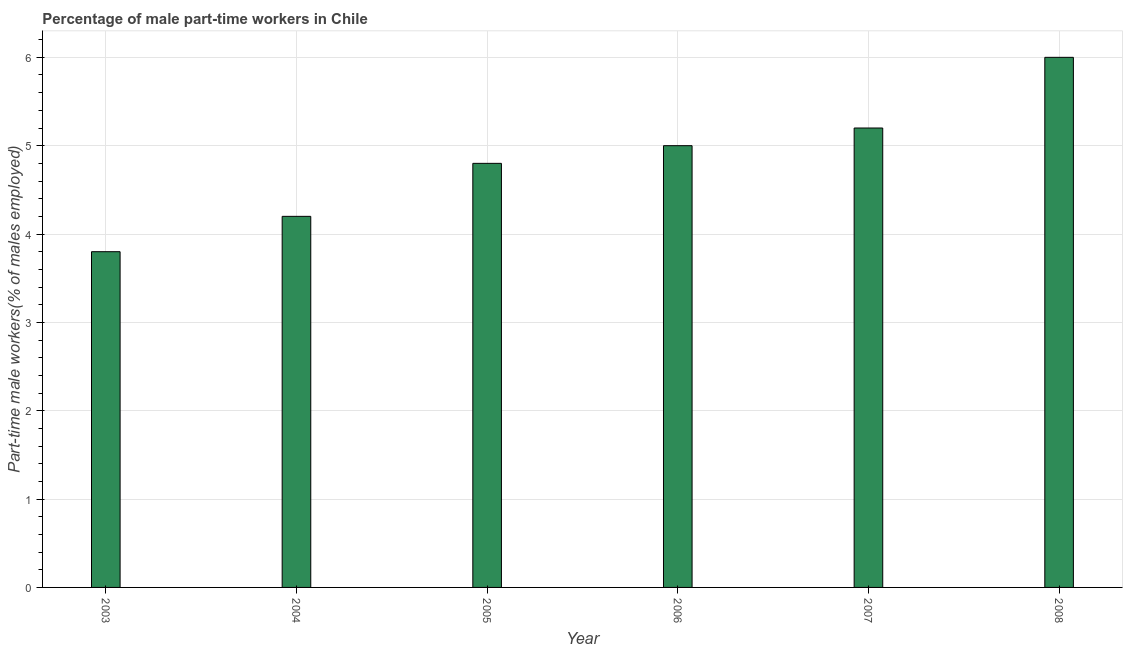Does the graph contain grids?
Keep it short and to the point. Yes. What is the title of the graph?
Give a very brief answer. Percentage of male part-time workers in Chile. What is the label or title of the Y-axis?
Offer a terse response. Part-time male workers(% of males employed). What is the percentage of part-time male workers in 2005?
Your answer should be compact. 4.8. Across all years, what is the maximum percentage of part-time male workers?
Offer a terse response. 6. Across all years, what is the minimum percentage of part-time male workers?
Give a very brief answer. 3.8. In which year was the percentage of part-time male workers maximum?
Provide a short and direct response. 2008. What is the sum of the percentage of part-time male workers?
Your answer should be compact. 29. What is the difference between the percentage of part-time male workers in 2005 and 2007?
Ensure brevity in your answer.  -0.4. What is the average percentage of part-time male workers per year?
Offer a very short reply. 4.83. What is the median percentage of part-time male workers?
Ensure brevity in your answer.  4.9. Do a majority of the years between 2008 and 2004 (inclusive) have percentage of part-time male workers greater than 1.8 %?
Your answer should be very brief. Yes. What is the ratio of the percentage of part-time male workers in 2003 to that in 2004?
Offer a terse response. 0.91. Is the percentage of part-time male workers in 2006 less than that in 2008?
Provide a short and direct response. Yes. Is the difference between the percentage of part-time male workers in 2003 and 2004 greater than the difference between any two years?
Your answer should be very brief. No. Is the sum of the percentage of part-time male workers in 2003 and 2008 greater than the maximum percentage of part-time male workers across all years?
Offer a very short reply. Yes. What is the difference between the highest and the lowest percentage of part-time male workers?
Provide a succinct answer. 2.2. In how many years, is the percentage of part-time male workers greater than the average percentage of part-time male workers taken over all years?
Give a very brief answer. 3. How many bars are there?
Offer a terse response. 6. Are all the bars in the graph horizontal?
Offer a very short reply. No. What is the difference between two consecutive major ticks on the Y-axis?
Give a very brief answer. 1. What is the Part-time male workers(% of males employed) in 2003?
Offer a very short reply. 3.8. What is the Part-time male workers(% of males employed) of 2004?
Keep it short and to the point. 4.2. What is the Part-time male workers(% of males employed) of 2005?
Offer a very short reply. 4.8. What is the Part-time male workers(% of males employed) in 2006?
Your response must be concise. 5. What is the Part-time male workers(% of males employed) in 2007?
Provide a succinct answer. 5.2. What is the Part-time male workers(% of males employed) in 2008?
Your answer should be very brief. 6. What is the difference between the Part-time male workers(% of males employed) in 2003 and 2004?
Offer a very short reply. -0.4. What is the difference between the Part-time male workers(% of males employed) in 2003 and 2005?
Your answer should be very brief. -1. What is the difference between the Part-time male workers(% of males employed) in 2003 and 2007?
Ensure brevity in your answer.  -1.4. What is the difference between the Part-time male workers(% of males employed) in 2004 and 2005?
Ensure brevity in your answer.  -0.6. What is the difference between the Part-time male workers(% of males employed) in 2005 and 2006?
Make the answer very short. -0.2. What is the difference between the Part-time male workers(% of males employed) in 2005 and 2007?
Keep it short and to the point. -0.4. What is the difference between the Part-time male workers(% of males employed) in 2006 and 2007?
Your answer should be compact. -0.2. What is the difference between the Part-time male workers(% of males employed) in 2006 and 2008?
Give a very brief answer. -1. What is the ratio of the Part-time male workers(% of males employed) in 2003 to that in 2004?
Make the answer very short. 0.91. What is the ratio of the Part-time male workers(% of males employed) in 2003 to that in 2005?
Your answer should be very brief. 0.79. What is the ratio of the Part-time male workers(% of males employed) in 2003 to that in 2006?
Offer a terse response. 0.76. What is the ratio of the Part-time male workers(% of males employed) in 2003 to that in 2007?
Offer a very short reply. 0.73. What is the ratio of the Part-time male workers(% of males employed) in 2003 to that in 2008?
Give a very brief answer. 0.63. What is the ratio of the Part-time male workers(% of males employed) in 2004 to that in 2006?
Provide a short and direct response. 0.84. What is the ratio of the Part-time male workers(% of males employed) in 2004 to that in 2007?
Offer a terse response. 0.81. What is the ratio of the Part-time male workers(% of males employed) in 2004 to that in 2008?
Your answer should be compact. 0.7. What is the ratio of the Part-time male workers(% of males employed) in 2005 to that in 2007?
Provide a short and direct response. 0.92. What is the ratio of the Part-time male workers(% of males employed) in 2005 to that in 2008?
Give a very brief answer. 0.8. What is the ratio of the Part-time male workers(% of males employed) in 2006 to that in 2007?
Give a very brief answer. 0.96. What is the ratio of the Part-time male workers(% of males employed) in 2006 to that in 2008?
Your answer should be very brief. 0.83. What is the ratio of the Part-time male workers(% of males employed) in 2007 to that in 2008?
Provide a short and direct response. 0.87. 